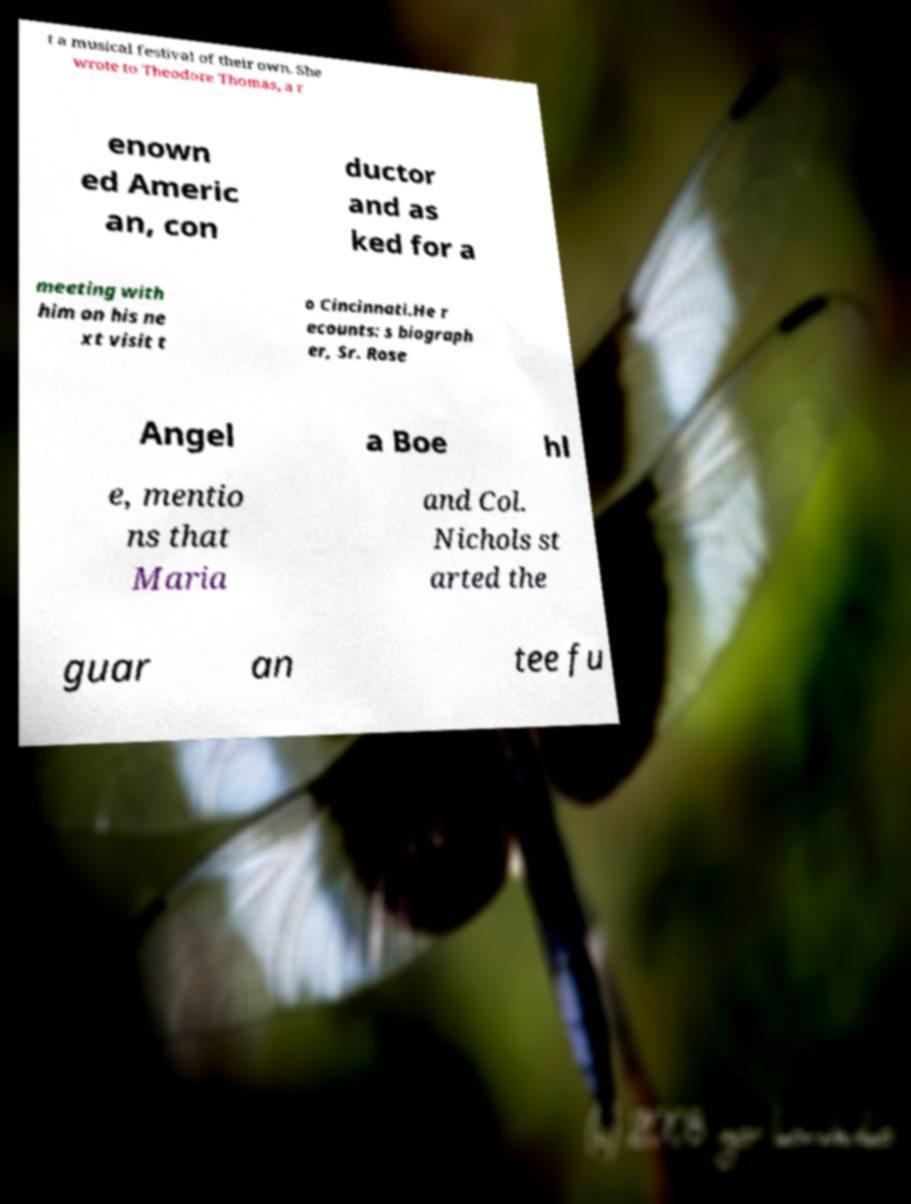Please identify and transcribe the text found in this image. t a musical festival of their own. She wrote to Theodore Thomas, a r enown ed Americ an, con ductor and as ked for a meeting with him on his ne xt visit t o Cincinnati.He r ecounts: s biograph er, Sr. Rose Angel a Boe hl e, mentio ns that Maria and Col. Nichols st arted the guar an tee fu 